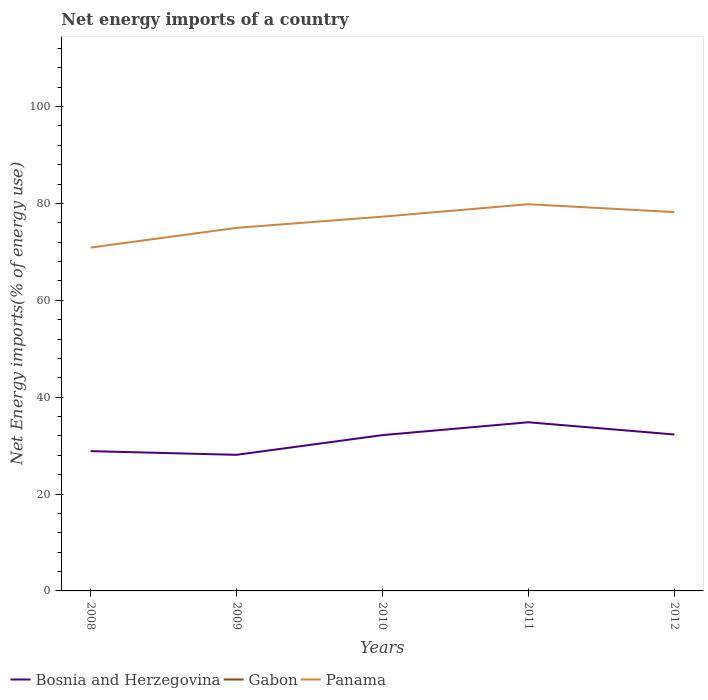How many different coloured lines are there?
Provide a succinct answer. 2. Does the line corresponding to Gabon intersect with the line corresponding to Panama?
Ensure brevity in your answer.  No. Across all years, what is the maximum net energy imports in Bosnia and Herzegovina?
Keep it short and to the point. 28.1. What is the total net energy imports in Bosnia and Herzegovina in the graph?
Keep it short and to the point. -4.2. What is the difference between the highest and the second highest net energy imports in Panama?
Your answer should be compact. 8.95. Is the net energy imports in Panama strictly greater than the net energy imports in Bosnia and Herzegovina over the years?
Your answer should be very brief. No. How many lines are there?
Make the answer very short. 2. How many years are there in the graph?
Provide a short and direct response. 5. Does the graph contain grids?
Offer a very short reply. No. How are the legend labels stacked?
Provide a succinct answer. Horizontal. What is the title of the graph?
Provide a succinct answer. Net energy imports of a country. What is the label or title of the X-axis?
Offer a terse response. Years. What is the label or title of the Y-axis?
Provide a succinct answer. Net Energy imports(% of energy use). What is the Net Energy imports(% of energy use) of Bosnia and Herzegovina in 2008?
Provide a short and direct response. 28.86. What is the Net Energy imports(% of energy use) of Panama in 2008?
Ensure brevity in your answer.  70.9. What is the Net Energy imports(% of energy use) of Bosnia and Herzegovina in 2009?
Provide a succinct answer. 28.1. What is the Net Energy imports(% of energy use) of Gabon in 2009?
Your answer should be compact. 0. What is the Net Energy imports(% of energy use) in Panama in 2009?
Offer a terse response. 74.97. What is the Net Energy imports(% of energy use) of Bosnia and Herzegovina in 2010?
Your answer should be compact. 32.17. What is the Net Energy imports(% of energy use) in Gabon in 2010?
Provide a short and direct response. 0. What is the Net Energy imports(% of energy use) of Panama in 2010?
Provide a succinct answer. 77.28. What is the Net Energy imports(% of energy use) in Bosnia and Herzegovina in 2011?
Offer a very short reply. 34.83. What is the Net Energy imports(% of energy use) in Panama in 2011?
Offer a terse response. 79.85. What is the Net Energy imports(% of energy use) of Bosnia and Herzegovina in 2012?
Ensure brevity in your answer.  32.3. What is the Net Energy imports(% of energy use) in Gabon in 2012?
Ensure brevity in your answer.  0. What is the Net Energy imports(% of energy use) in Panama in 2012?
Ensure brevity in your answer.  78.22. Across all years, what is the maximum Net Energy imports(% of energy use) of Bosnia and Herzegovina?
Offer a very short reply. 34.83. Across all years, what is the maximum Net Energy imports(% of energy use) of Panama?
Your response must be concise. 79.85. Across all years, what is the minimum Net Energy imports(% of energy use) in Bosnia and Herzegovina?
Keep it short and to the point. 28.1. Across all years, what is the minimum Net Energy imports(% of energy use) in Panama?
Provide a succinct answer. 70.9. What is the total Net Energy imports(% of energy use) of Bosnia and Herzegovina in the graph?
Provide a short and direct response. 156.26. What is the total Net Energy imports(% of energy use) in Gabon in the graph?
Give a very brief answer. 0. What is the total Net Energy imports(% of energy use) in Panama in the graph?
Make the answer very short. 381.21. What is the difference between the Net Energy imports(% of energy use) in Bosnia and Herzegovina in 2008 and that in 2009?
Provide a short and direct response. 0.76. What is the difference between the Net Energy imports(% of energy use) of Panama in 2008 and that in 2009?
Your response must be concise. -4.07. What is the difference between the Net Energy imports(% of energy use) of Bosnia and Herzegovina in 2008 and that in 2010?
Offer a terse response. -3.31. What is the difference between the Net Energy imports(% of energy use) of Panama in 2008 and that in 2010?
Provide a short and direct response. -6.38. What is the difference between the Net Energy imports(% of energy use) in Bosnia and Herzegovina in 2008 and that in 2011?
Your answer should be very brief. -5.96. What is the difference between the Net Energy imports(% of energy use) in Panama in 2008 and that in 2011?
Give a very brief answer. -8.95. What is the difference between the Net Energy imports(% of energy use) of Bosnia and Herzegovina in 2008 and that in 2012?
Your answer should be compact. -3.44. What is the difference between the Net Energy imports(% of energy use) in Panama in 2008 and that in 2012?
Your answer should be compact. -7.33. What is the difference between the Net Energy imports(% of energy use) of Bosnia and Herzegovina in 2009 and that in 2010?
Make the answer very short. -4.07. What is the difference between the Net Energy imports(% of energy use) of Panama in 2009 and that in 2010?
Offer a very short reply. -2.31. What is the difference between the Net Energy imports(% of energy use) in Bosnia and Herzegovina in 2009 and that in 2011?
Offer a very short reply. -6.72. What is the difference between the Net Energy imports(% of energy use) of Panama in 2009 and that in 2011?
Provide a succinct answer. -4.88. What is the difference between the Net Energy imports(% of energy use) of Bosnia and Herzegovina in 2009 and that in 2012?
Your response must be concise. -4.2. What is the difference between the Net Energy imports(% of energy use) of Panama in 2009 and that in 2012?
Your answer should be compact. -3.26. What is the difference between the Net Energy imports(% of energy use) of Bosnia and Herzegovina in 2010 and that in 2011?
Your answer should be very brief. -2.65. What is the difference between the Net Energy imports(% of energy use) of Panama in 2010 and that in 2011?
Offer a very short reply. -2.57. What is the difference between the Net Energy imports(% of energy use) in Bosnia and Herzegovina in 2010 and that in 2012?
Keep it short and to the point. -0.13. What is the difference between the Net Energy imports(% of energy use) in Panama in 2010 and that in 2012?
Keep it short and to the point. -0.95. What is the difference between the Net Energy imports(% of energy use) of Bosnia and Herzegovina in 2011 and that in 2012?
Make the answer very short. 2.53. What is the difference between the Net Energy imports(% of energy use) in Panama in 2011 and that in 2012?
Your answer should be very brief. 1.62. What is the difference between the Net Energy imports(% of energy use) in Bosnia and Herzegovina in 2008 and the Net Energy imports(% of energy use) in Panama in 2009?
Ensure brevity in your answer.  -46.11. What is the difference between the Net Energy imports(% of energy use) of Bosnia and Herzegovina in 2008 and the Net Energy imports(% of energy use) of Panama in 2010?
Make the answer very short. -48.42. What is the difference between the Net Energy imports(% of energy use) in Bosnia and Herzegovina in 2008 and the Net Energy imports(% of energy use) in Panama in 2011?
Your answer should be compact. -50.98. What is the difference between the Net Energy imports(% of energy use) of Bosnia and Herzegovina in 2008 and the Net Energy imports(% of energy use) of Panama in 2012?
Offer a very short reply. -49.36. What is the difference between the Net Energy imports(% of energy use) of Bosnia and Herzegovina in 2009 and the Net Energy imports(% of energy use) of Panama in 2010?
Give a very brief answer. -49.18. What is the difference between the Net Energy imports(% of energy use) in Bosnia and Herzegovina in 2009 and the Net Energy imports(% of energy use) in Panama in 2011?
Provide a short and direct response. -51.74. What is the difference between the Net Energy imports(% of energy use) in Bosnia and Herzegovina in 2009 and the Net Energy imports(% of energy use) in Panama in 2012?
Offer a very short reply. -50.12. What is the difference between the Net Energy imports(% of energy use) in Bosnia and Herzegovina in 2010 and the Net Energy imports(% of energy use) in Panama in 2011?
Your answer should be very brief. -47.68. What is the difference between the Net Energy imports(% of energy use) of Bosnia and Herzegovina in 2010 and the Net Energy imports(% of energy use) of Panama in 2012?
Keep it short and to the point. -46.05. What is the difference between the Net Energy imports(% of energy use) of Bosnia and Herzegovina in 2011 and the Net Energy imports(% of energy use) of Panama in 2012?
Offer a very short reply. -43.4. What is the average Net Energy imports(% of energy use) of Bosnia and Herzegovina per year?
Provide a succinct answer. 31.25. What is the average Net Energy imports(% of energy use) in Panama per year?
Your response must be concise. 76.24. In the year 2008, what is the difference between the Net Energy imports(% of energy use) in Bosnia and Herzegovina and Net Energy imports(% of energy use) in Panama?
Give a very brief answer. -42.04. In the year 2009, what is the difference between the Net Energy imports(% of energy use) of Bosnia and Herzegovina and Net Energy imports(% of energy use) of Panama?
Make the answer very short. -46.87. In the year 2010, what is the difference between the Net Energy imports(% of energy use) of Bosnia and Herzegovina and Net Energy imports(% of energy use) of Panama?
Ensure brevity in your answer.  -45.11. In the year 2011, what is the difference between the Net Energy imports(% of energy use) of Bosnia and Herzegovina and Net Energy imports(% of energy use) of Panama?
Give a very brief answer. -45.02. In the year 2012, what is the difference between the Net Energy imports(% of energy use) in Bosnia and Herzegovina and Net Energy imports(% of energy use) in Panama?
Your response must be concise. -45.93. What is the ratio of the Net Energy imports(% of energy use) in Panama in 2008 to that in 2009?
Provide a succinct answer. 0.95. What is the ratio of the Net Energy imports(% of energy use) in Bosnia and Herzegovina in 2008 to that in 2010?
Give a very brief answer. 0.9. What is the ratio of the Net Energy imports(% of energy use) in Panama in 2008 to that in 2010?
Keep it short and to the point. 0.92. What is the ratio of the Net Energy imports(% of energy use) of Bosnia and Herzegovina in 2008 to that in 2011?
Provide a short and direct response. 0.83. What is the ratio of the Net Energy imports(% of energy use) in Panama in 2008 to that in 2011?
Make the answer very short. 0.89. What is the ratio of the Net Energy imports(% of energy use) of Bosnia and Herzegovina in 2008 to that in 2012?
Ensure brevity in your answer.  0.89. What is the ratio of the Net Energy imports(% of energy use) of Panama in 2008 to that in 2012?
Offer a terse response. 0.91. What is the ratio of the Net Energy imports(% of energy use) in Bosnia and Herzegovina in 2009 to that in 2010?
Keep it short and to the point. 0.87. What is the ratio of the Net Energy imports(% of energy use) in Panama in 2009 to that in 2010?
Provide a short and direct response. 0.97. What is the ratio of the Net Energy imports(% of energy use) in Bosnia and Herzegovina in 2009 to that in 2011?
Provide a succinct answer. 0.81. What is the ratio of the Net Energy imports(% of energy use) of Panama in 2009 to that in 2011?
Provide a succinct answer. 0.94. What is the ratio of the Net Energy imports(% of energy use) of Bosnia and Herzegovina in 2009 to that in 2012?
Offer a very short reply. 0.87. What is the ratio of the Net Energy imports(% of energy use) in Panama in 2009 to that in 2012?
Your answer should be compact. 0.96. What is the ratio of the Net Energy imports(% of energy use) of Bosnia and Herzegovina in 2010 to that in 2011?
Provide a short and direct response. 0.92. What is the ratio of the Net Energy imports(% of energy use) in Panama in 2010 to that in 2011?
Offer a terse response. 0.97. What is the ratio of the Net Energy imports(% of energy use) in Panama in 2010 to that in 2012?
Keep it short and to the point. 0.99. What is the ratio of the Net Energy imports(% of energy use) of Bosnia and Herzegovina in 2011 to that in 2012?
Ensure brevity in your answer.  1.08. What is the ratio of the Net Energy imports(% of energy use) in Panama in 2011 to that in 2012?
Keep it short and to the point. 1.02. What is the difference between the highest and the second highest Net Energy imports(% of energy use) in Bosnia and Herzegovina?
Make the answer very short. 2.53. What is the difference between the highest and the second highest Net Energy imports(% of energy use) of Panama?
Provide a short and direct response. 1.62. What is the difference between the highest and the lowest Net Energy imports(% of energy use) of Bosnia and Herzegovina?
Make the answer very short. 6.72. What is the difference between the highest and the lowest Net Energy imports(% of energy use) of Panama?
Make the answer very short. 8.95. 